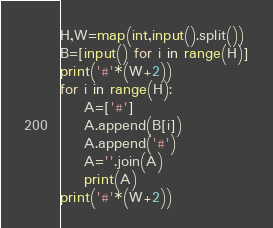Convert code to text. <code><loc_0><loc_0><loc_500><loc_500><_Python_>H,W=map(int,input().split())
B=[input() for i in range(H)]
print('#'*(W+2))
for i in range(H):
    A=['#']
    A.append(B[i])
    A.append('#')
    A=''.join(A)
    print(A)
print('#'*(W+2))</code> 